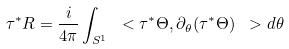<formula> <loc_0><loc_0><loc_500><loc_500>\tau ^ { * } R = \frac { i } { 4 \pi } \int _ { S ^ { 1 } } \ < \tau ^ { * } \Theta , \partial _ { \theta } ( \tau ^ { * } \Theta ) \ > d \theta</formula> 